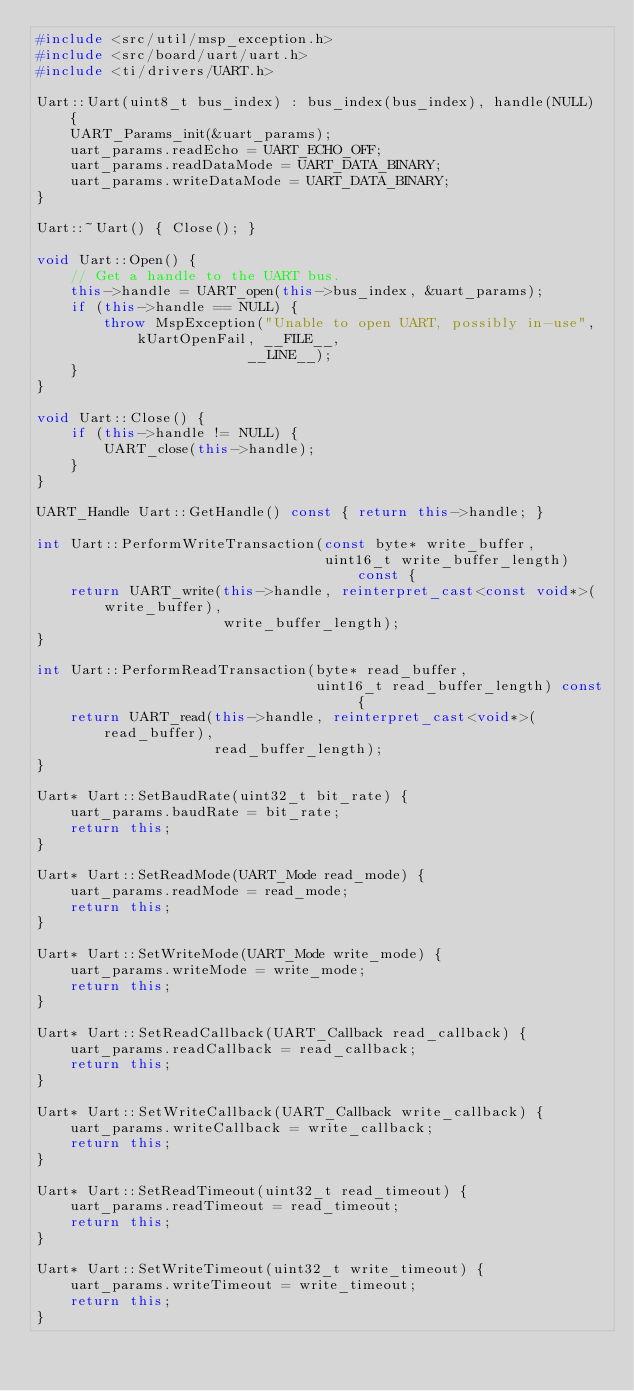Convert code to text. <code><loc_0><loc_0><loc_500><loc_500><_C++_>#include <src/util/msp_exception.h>
#include <src/board/uart/uart.h>
#include <ti/drivers/UART.h>

Uart::Uart(uint8_t bus_index) : bus_index(bus_index), handle(NULL) {
    UART_Params_init(&uart_params);
    uart_params.readEcho = UART_ECHO_OFF;
    uart_params.readDataMode = UART_DATA_BINARY;
    uart_params.writeDataMode = UART_DATA_BINARY;
}

Uart::~Uart() { Close(); }

void Uart::Open() {
    // Get a handle to the UART bus.
    this->handle = UART_open(this->bus_index, &uart_params);
    if (this->handle == NULL) {
        throw MspException("Unable to open UART, possibly in-use", kUartOpenFail, __FILE__,
                         __LINE__);
    }
}

void Uart::Close() {
    if (this->handle != NULL) {
        UART_close(this->handle);
    }
}

UART_Handle Uart::GetHandle() const { return this->handle; }

int Uart::PerformWriteTransaction(const byte* write_buffer,
                                  uint16_t write_buffer_length) const {
    return UART_write(this->handle, reinterpret_cast<const void*>(write_buffer),
                      write_buffer_length);
}

int Uart::PerformReadTransaction(byte* read_buffer,
                                 uint16_t read_buffer_length) const {
    return UART_read(this->handle, reinterpret_cast<void*>(read_buffer),
                     read_buffer_length);
}

Uart* Uart::SetBaudRate(uint32_t bit_rate) {
    uart_params.baudRate = bit_rate;
    return this;
}

Uart* Uart::SetReadMode(UART_Mode read_mode) {
    uart_params.readMode = read_mode;
    return this;
}

Uart* Uart::SetWriteMode(UART_Mode write_mode) {
    uart_params.writeMode = write_mode;
    return this;
}

Uart* Uart::SetReadCallback(UART_Callback read_callback) {
    uart_params.readCallback = read_callback;
    return this;
}

Uart* Uart::SetWriteCallback(UART_Callback write_callback) {
    uart_params.writeCallback = write_callback;
    return this;
}

Uart* Uart::SetReadTimeout(uint32_t read_timeout) {
    uart_params.readTimeout = read_timeout;
    return this;
}

Uart* Uart::SetWriteTimeout(uint32_t write_timeout) {
    uart_params.writeTimeout = write_timeout;
    return this;
}
</code> 